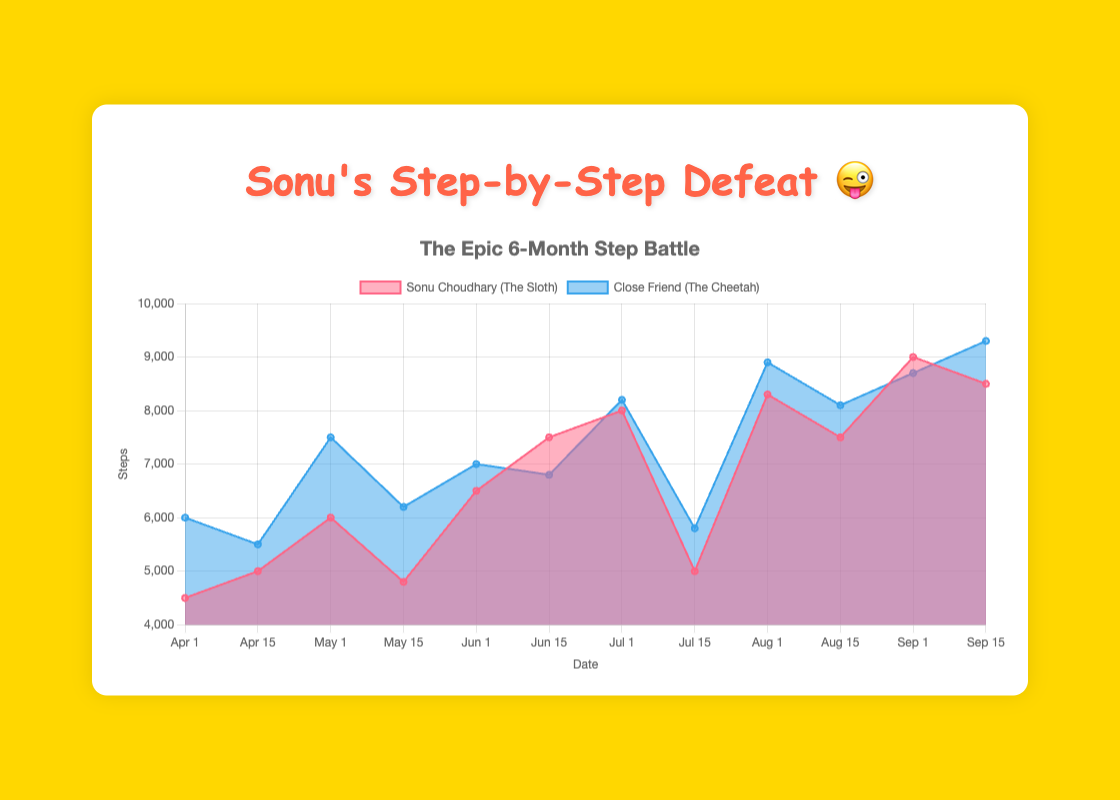What is the title of the chart? The title is prominently displayed at the top of the chart, indicating the main focus of the data. It reads "The Epic 6-Month Step Battle".
Answer: The Epic 6-Month Step Battle How many dates are represented in the chart? By counting the data points along the x-axis, which are labeled with the dates, there are 12 data points from April 1 to September 15.
Answer: 12 Which color represents Sonu Choudhary's step count? The data for Sonu Choudhary is shown using an area filled with a reddish color and borders of the same color. The label in the legend confirms this.
Answer: Reddish color Who had more steps on July 1, Sonu or the Close Friend? By observing the heights of the respective areas on the chart at the July 1 data point and confirming via the y-axis, the Close Friend had slightly more steps (8200) compared to Sonu (8000).
Answer: Close Friend What was the largest step count by Sonu Choudhary? By looking at the peaks of Sonu's area chart, the highest point is reached on September 1, showing 9000 steps.
Answer: 9000 Did Sonu Choudhary ever have more steps than the Close Friend? If so, when? Comparing the two areas at different points in the chart, Sonu surpasses the Close Friend only on June 15 (7500 steps vs. Close Friend's 6800) and on September 1 (9000 steps vs. Close Friend's 8700).
Answer: June 15 and September 1 What is the difference in steps between Sonu and the Close Friend on May 1? By locating the May 1 data point, Sonu's steps are 6000 and the Close Friend's steps are 7500. The difference is 7500 - 6000 = 1500 steps.
Answer: 1500 On which date did Sonu have the least steps? Viewing the lowest points on Sonu's area, the fewest steps occur on April 1 with 4500 steps.
Answer: April 1 Calculate the average step count for Sonu Choudhary over the six-month period. Adding all of Sonu's step counts gives 4500 + 5000 + 6000 + 4800 + 6500 + 7500 + 8000 + 5000 + 8300 + 7500 + 9000 + 8500 = 80600 steps. Divide the total by 12 data points: 80600 / 12 ≈ 6716.67 steps.
Answer: Approximately 6717 steps Between August 1 and August 15, did Sonu's step count increase or decrease, and by how much? Sonu's step count on August 1 was 8300, and on August 15 it was 7500. The change is 7500 - 8300 = -800 steps, indicating a decrease.
Answer: Decreased by 800 steps 